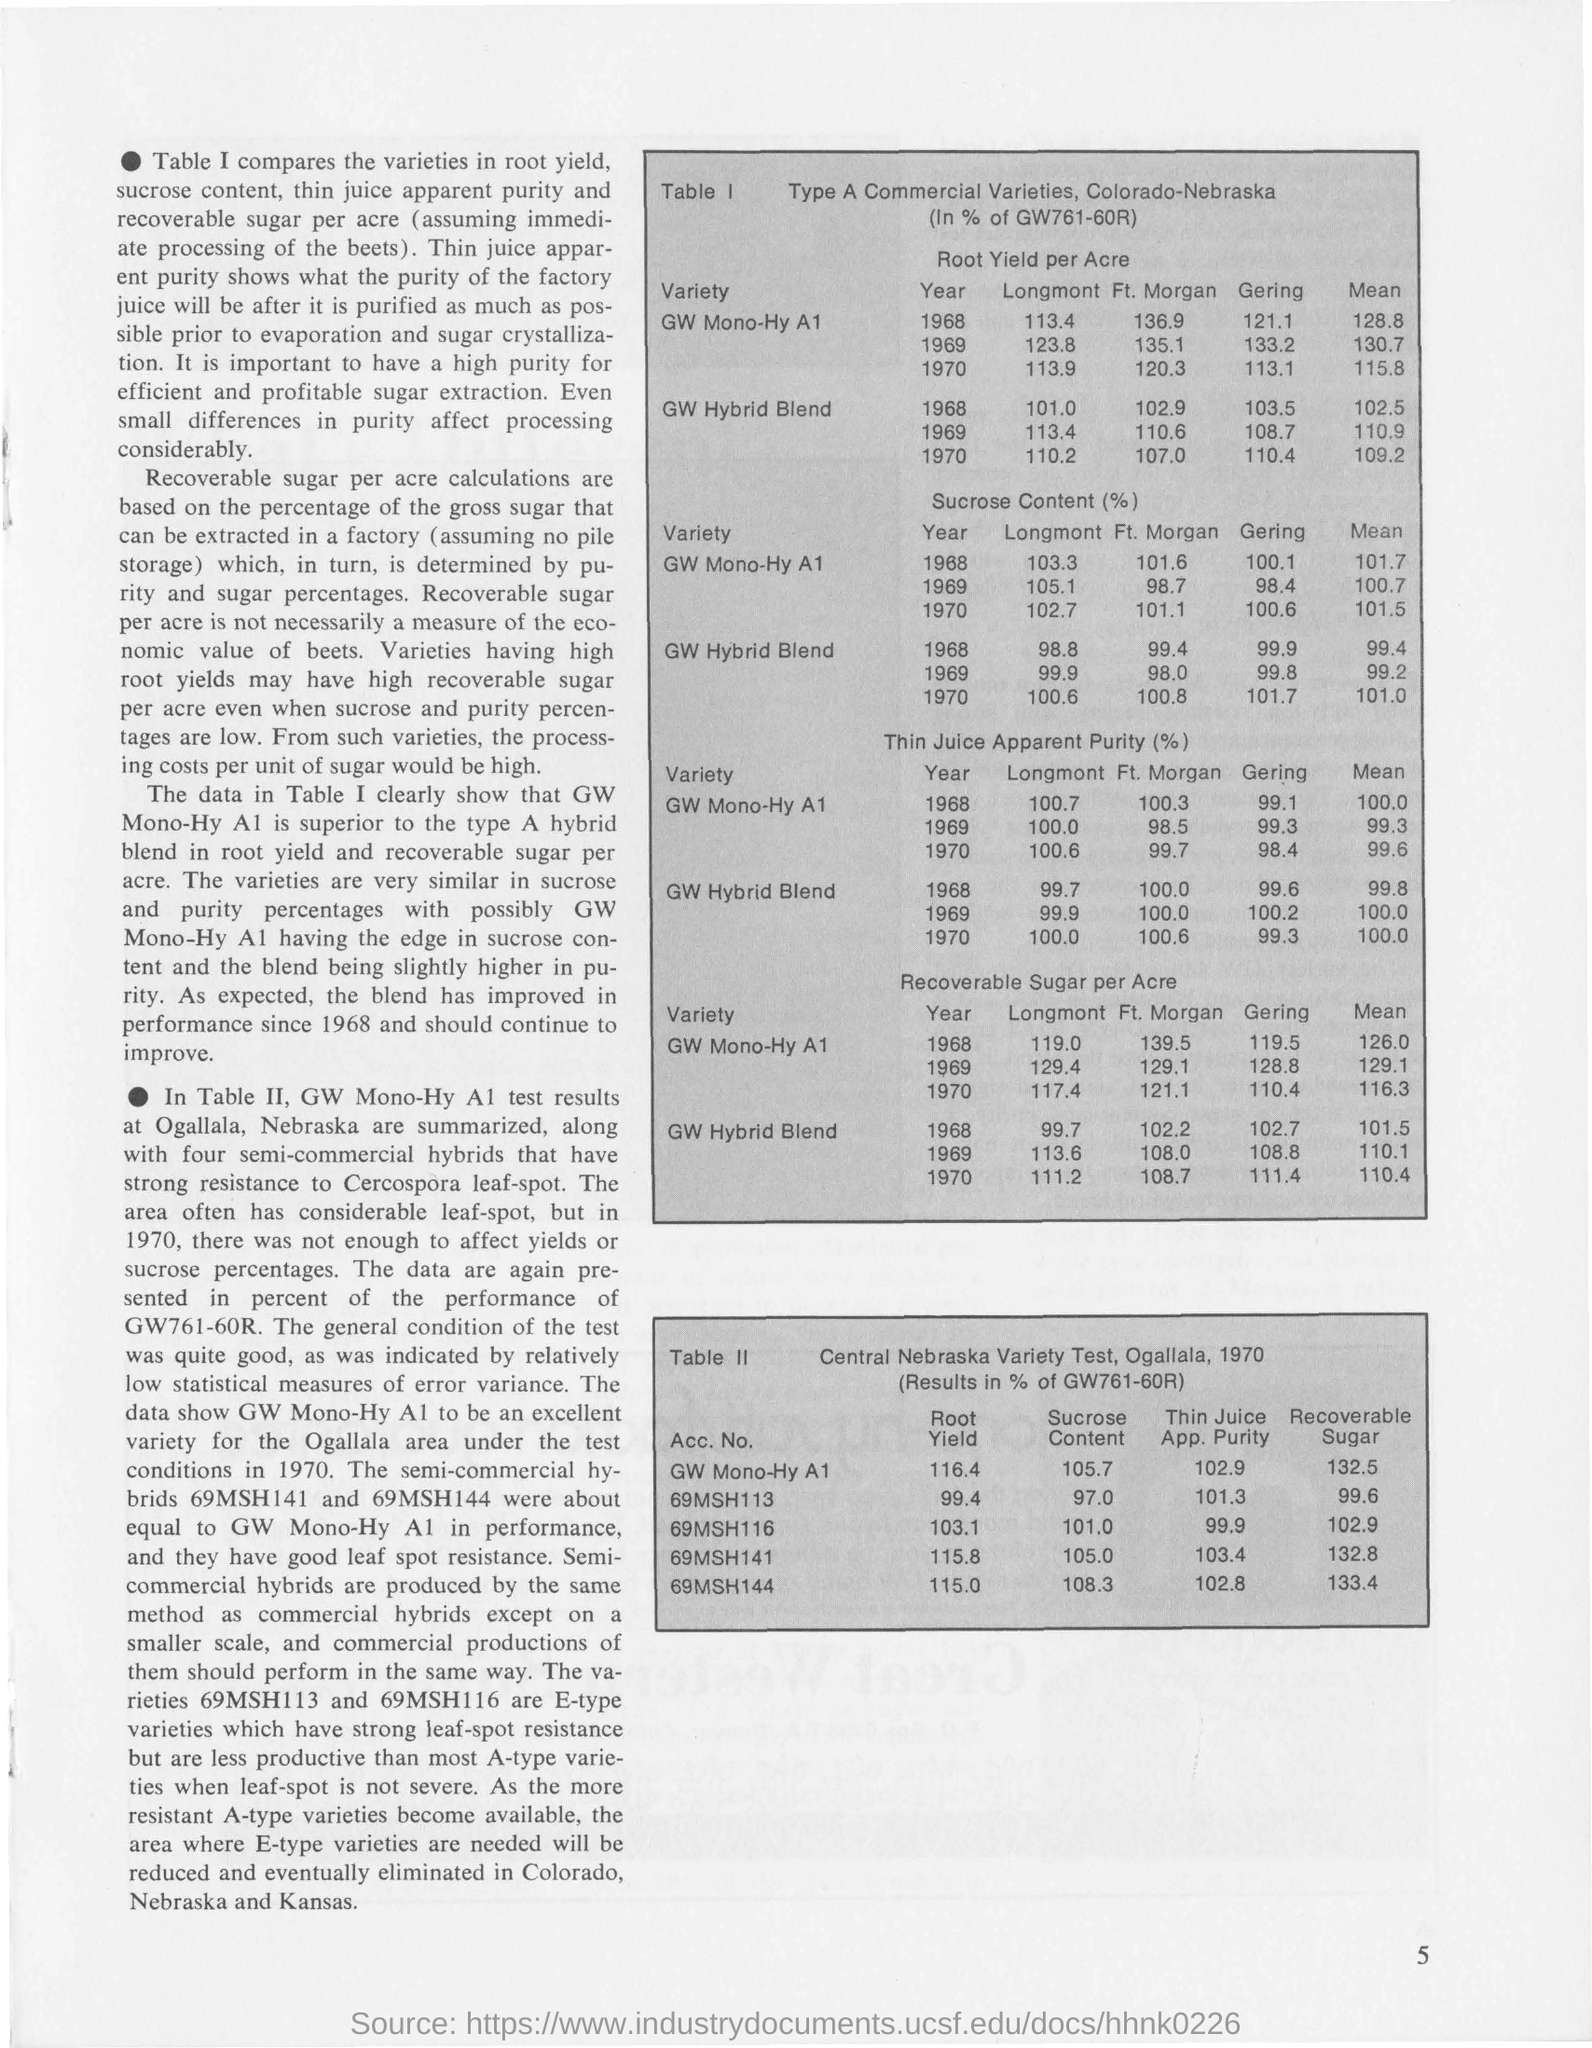Specify some key components in this picture. The Table II shows the results of the Central Nebraska Variety Test conducted in Ogallala in 1970, using GW761-60R as a reference. The table shows the type and commercial varieties of wheat grown in Colorado and Nebraska, with the percentages represented as GW761-60R. The mean of the GW Hybrid Blend by recoverable sugar per acre in 1969, as shown in Table I, was 110.1 units. The Thin Juice App is a program that focuses on the purity of 69MSH144, which is listed in Table II with a value of 102.8%. 